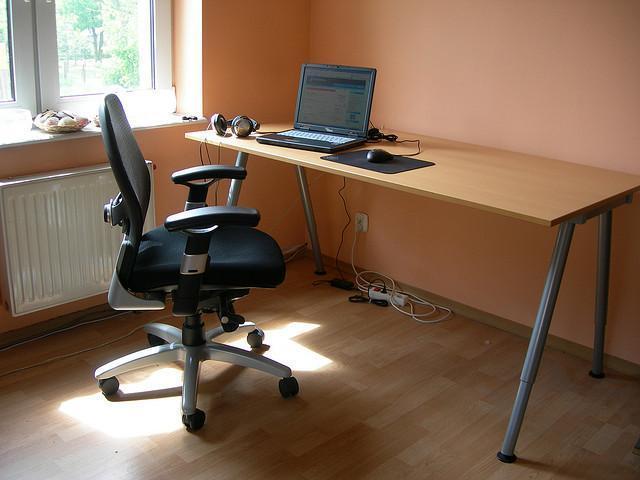How many wheels on the chair?
Give a very brief answer. 5. How many people are wearing hats?
Give a very brief answer. 0. 